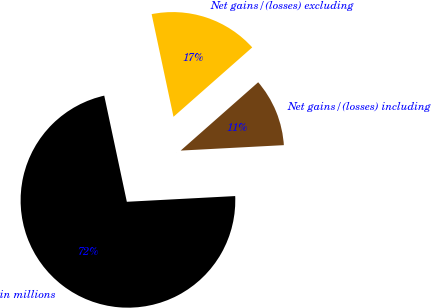<chart> <loc_0><loc_0><loc_500><loc_500><pie_chart><fcel>in millions<fcel>Net gains/(losses) including<fcel>Net gains/(losses) excluding<nl><fcel>72.5%<fcel>10.66%<fcel>16.84%<nl></chart> 